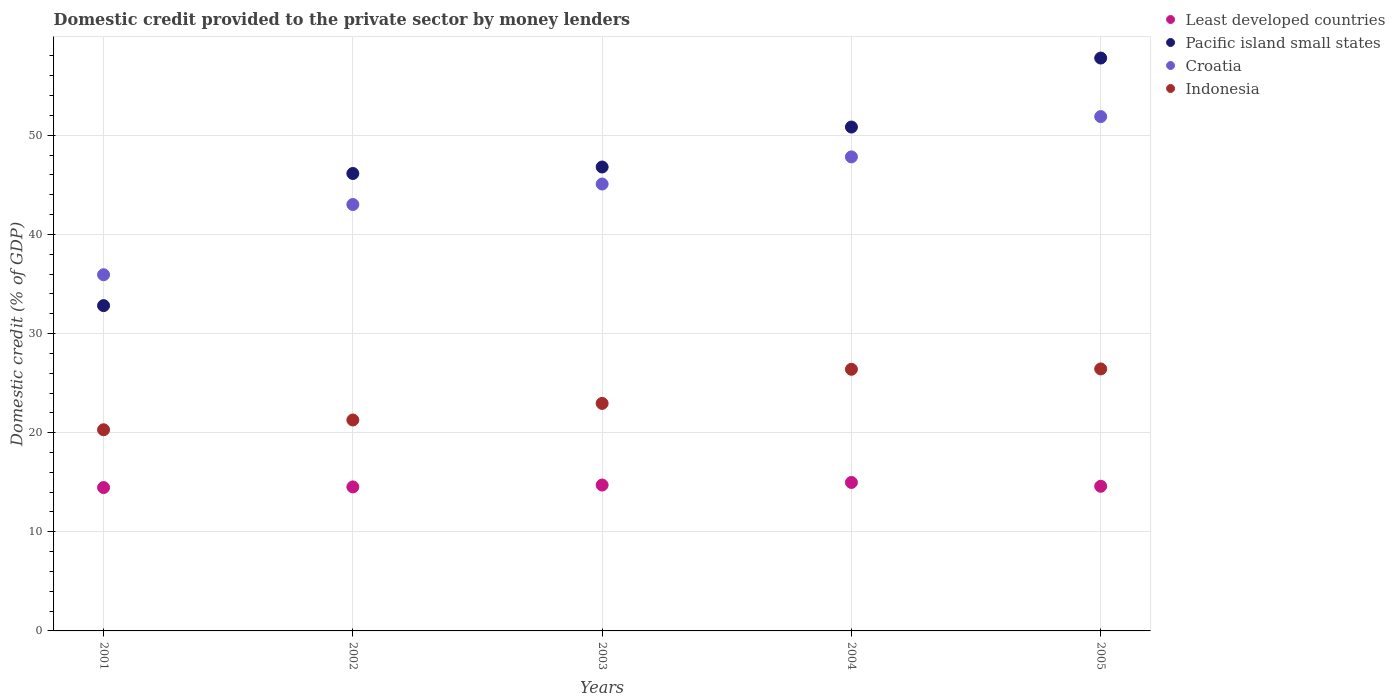What is the domestic credit provided to the private sector by money lenders in Least developed countries in 2001?
Keep it short and to the point. 14.46. Across all years, what is the maximum domestic credit provided to the private sector by money lenders in Least developed countries?
Your response must be concise. 14.98. Across all years, what is the minimum domestic credit provided to the private sector by money lenders in Pacific island small states?
Ensure brevity in your answer.  32.81. In which year was the domestic credit provided to the private sector by money lenders in Croatia maximum?
Provide a succinct answer. 2005. What is the total domestic credit provided to the private sector by money lenders in Indonesia in the graph?
Provide a short and direct response. 117.34. What is the difference between the domestic credit provided to the private sector by money lenders in Pacific island small states in 2003 and that in 2004?
Offer a very short reply. -4.03. What is the difference between the domestic credit provided to the private sector by money lenders in Croatia in 2002 and the domestic credit provided to the private sector by money lenders in Indonesia in 2005?
Offer a terse response. 16.59. What is the average domestic credit provided to the private sector by money lenders in Croatia per year?
Offer a very short reply. 44.74. In the year 2001, what is the difference between the domestic credit provided to the private sector by money lenders in Croatia and domestic credit provided to the private sector by money lenders in Least developed countries?
Offer a terse response. 21.47. What is the ratio of the domestic credit provided to the private sector by money lenders in Pacific island small states in 2001 to that in 2005?
Provide a succinct answer. 0.57. What is the difference between the highest and the second highest domestic credit provided to the private sector by money lenders in Indonesia?
Give a very brief answer. 0.04. What is the difference between the highest and the lowest domestic credit provided to the private sector by money lenders in Croatia?
Provide a short and direct response. 15.95. Is it the case that in every year, the sum of the domestic credit provided to the private sector by money lenders in Least developed countries and domestic credit provided to the private sector by money lenders in Croatia  is greater than the sum of domestic credit provided to the private sector by money lenders in Pacific island small states and domestic credit provided to the private sector by money lenders in Indonesia?
Give a very brief answer. Yes. Is it the case that in every year, the sum of the domestic credit provided to the private sector by money lenders in Least developed countries and domestic credit provided to the private sector by money lenders in Pacific island small states  is greater than the domestic credit provided to the private sector by money lenders in Croatia?
Your response must be concise. Yes. Is the domestic credit provided to the private sector by money lenders in Pacific island small states strictly greater than the domestic credit provided to the private sector by money lenders in Croatia over the years?
Your answer should be compact. No. Is the domestic credit provided to the private sector by money lenders in Pacific island small states strictly less than the domestic credit provided to the private sector by money lenders in Croatia over the years?
Offer a very short reply. No. How many dotlines are there?
Ensure brevity in your answer.  4. What is the difference between two consecutive major ticks on the Y-axis?
Your answer should be very brief. 10. Are the values on the major ticks of Y-axis written in scientific E-notation?
Your answer should be very brief. No. Does the graph contain grids?
Provide a short and direct response. Yes. How many legend labels are there?
Offer a very short reply. 4. How are the legend labels stacked?
Your answer should be compact. Vertical. What is the title of the graph?
Give a very brief answer. Domestic credit provided to the private sector by money lenders. Does "Bangladesh" appear as one of the legend labels in the graph?
Keep it short and to the point. No. What is the label or title of the Y-axis?
Keep it short and to the point. Domestic credit (% of GDP). What is the Domestic credit (% of GDP) of Least developed countries in 2001?
Your answer should be very brief. 14.46. What is the Domestic credit (% of GDP) of Pacific island small states in 2001?
Your response must be concise. 32.81. What is the Domestic credit (% of GDP) of Croatia in 2001?
Your answer should be very brief. 35.93. What is the Domestic credit (% of GDP) in Indonesia in 2001?
Your response must be concise. 20.29. What is the Domestic credit (% of GDP) of Least developed countries in 2002?
Give a very brief answer. 14.53. What is the Domestic credit (% of GDP) in Pacific island small states in 2002?
Provide a succinct answer. 46.14. What is the Domestic credit (% of GDP) of Croatia in 2002?
Make the answer very short. 43.01. What is the Domestic credit (% of GDP) of Indonesia in 2002?
Offer a terse response. 21.28. What is the Domestic credit (% of GDP) of Least developed countries in 2003?
Your answer should be very brief. 14.72. What is the Domestic credit (% of GDP) in Pacific island small states in 2003?
Offer a terse response. 46.8. What is the Domestic credit (% of GDP) in Croatia in 2003?
Give a very brief answer. 45.08. What is the Domestic credit (% of GDP) in Indonesia in 2003?
Provide a succinct answer. 22.95. What is the Domestic credit (% of GDP) in Least developed countries in 2004?
Make the answer very short. 14.98. What is the Domestic credit (% of GDP) in Pacific island small states in 2004?
Offer a very short reply. 50.83. What is the Domestic credit (% of GDP) of Croatia in 2004?
Make the answer very short. 47.82. What is the Domestic credit (% of GDP) in Indonesia in 2004?
Provide a short and direct response. 26.39. What is the Domestic credit (% of GDP) of Least developed countries in 2005?
Offer a very short reply. 14.59. What is the Domestic credit (% of GDP) in Pacific island small states in 2005?
Ensure brevity in your answer.  57.79. What is the Domestic credit (% of GDP) in Croatia in 2005?
Give a very brief answer. 51.88. What is the Domestic credit (% of GDP) of Indonesia in 2005?
Make the answer very short. 26.43. Across all years, what is the maximum Domestic credit (% of GDP) in Least developed countries?
Ensure brevity in your answer.  14.98. Across all years, what is the maximum Domestic credit (% of GDP) of Pacific island small states?
Your response must be concise. 57.79. Across all years, what is the maximum Domestic credit (% of GDP) in Croatia?
Make the answer very short. 51.88. Across all years, what is the maximum Domestic credit (% of GDP) of Indonesia?
Offer a very short reply. 26.43. Across all years, what is the minimum Domestic credit (% of GDP) of Least developed countries?
Your response must be concise. 14.46. Across all years, what is the minimum Domestic credit (% of GDP) in Pacific island small states?
Offer a very short reply. 32.81. Across all years, what is the minimum Domestic credit (% of GDP) of Croatia?
Ensure brevity in your answer.  35.93. Across all years, what is the minimum Domestic credit (% of GDP) in Indonesia?
Your answer should be very brief. 20.29. What is the total Domestic credit (% of GDP) of Least developed countries in the graph?
Make the answer very short. 73.27. What is the total Domestic credit (% of GDP) of Pacific island small states in the graph?
Provide a succinct answer. 234.37. What is the total Domestic credit (% of GDP) of Croatia in the graph?
Provide a succinct answer. 223.72. What is the total Domestic credit (% of GDP) of Indonesia in the graph?
Your answer should be compact. 117.34. What is the difference between the Domestic credit (% of GDP) in Least developed countries in 2001 and that in 2002?
Your answer should be very brief. -0.06. What is the difference between the Domestic credit (% of GDP) in Pacific island small states in 2001 and that in 2002?
Your answer should be very brief. -13.33. What is the difference between the Domestic credit (% of GDP) of Croatia in 2001 and that in 2002?
Keep it short and to the point. -7.08. What is the difference between the Domestic credit (% of GDP) in Indonesia in 2001 and that in 2002?
Keep it short and to the point. -0.99. What is the difference between the Domestic credit (% of GDP) of Least developed countries in 2001 and that in 2003?
Ensure brevity in your answer.  -0.25. What is the difference between the Domestic credit (% of GDP) in Pacific island small states in 2001 and that in 2003?
Your response must be concise. -13.98. What is the difference between the Domestic credit (% of GDP) in Croatia in 2001 and that in 2003?
Ensure brevity in your answer.  -9.15. What is the difference between the Domestic credit (% of GDP) in Indonesia in 2001 and that in 2003?
Give a very brief answer. -2.66. What is the difference between the Domestic credit (% of GDP) in Least developed countries in 2001 and that in 2004?
Make the answer very short. -0.51. What is the difference between the Domestic credit (% of GDP) of Pacific island small states in 2001 and that in 2004?
Ensure brevity in your answer.  -18.01. What is the difference between the Domestic credit (% of GDP) of Croatia in 2001 and that in 2004?
Offer a terse response. -11.89. What is the difference between the Domestic credit (% of GDP) of Indonesia in 2001 and that in 2004?
Ensure brevity in your answer.  -6.1. What is the difference between the Domestic credit (% of GDP) of Least developed countries in 2001 and that in 2005?
Offer a terse response. -0.13. What is the difference between the Domestic credit (% of GDP) of Pacific island small states in 2001 and that in 2005?
Ensure brevity in your answer.  -24.97. What is the difference between the Domestic credit (% of GDP) in Croatia in 2001 and that in 2005?
Offer a very short reply. -15.95. What is the difference between the Domestic credit (% of GDP) of Indonesia in 2001 and that in 2005?
Your answer should be compact. -6.14. What is the difference between the Domestic credit (% of GDP) of Least developed countries in 2002 and that in 2003?
Give a very brief answer. -0.19. What is the difference between the Domestic credit (% of GDP) in Pacific island small states in 2002 and that in 2003?
Provide a short and direct response. -0.65. What is the difference between the Domestic credit (% of GDP) in Croatia in 2002 and that in 2003?
Your answer should be compact. -2.07. What is the difference between the Domestic credit (% of GDP) in Indonesia in 2002 and that in 2003?
Offer a very short reply. -1.67. What is the difference between the Domestic credit (% of GDP) in Least developed countries in 2002 and that in 2004?
Make the answer very short. -0.45. What is the difference between the Domestic credit (% of GDP) in Pacific island small states in 2002 and that in 2004?
Offer a terse response. -4.69. What is the difference between the Domestic credit (% of GDP) in Croatia in 2002 and that in 2004?
Your response must be concise. -4.8. What is the difference between the Domestic credit (% of GDP) of Indonesia in 2002 and that in 2004?
Keep it short and to the point. -5.12. What is the difference between the Domestic credit (% of GDP) of Least developed countries in 2002 and that in 2005?
Your answer should be compact. -0.07. What is the difference between the Domestic credit (% of GDP) in Pacific island small states in 2002 and that in 2005?
Your answer should be very brief. -11.64. What is the difference between the Domestic credit (% of GDP) of Croatia in 2002 and that in 2005?
Give a very brief answer. -8.87. What is the difference between the Domestic credit (% of GDP) in Indonesia in 2002 and that in 2005?
Your answer should be compact. -5.15. What is the difference between the Domestic credit (% of GDP) in Least developed countries in 2003 and that in 2004?
Your answer should be very brief. -0.26. What is the difference between the Domestic credit (% of GDP) in Pacific island small states in 2003 and that in 2004?
Make the answer very short. -4.03. What is the difference between the Domestic credit (% of GDP) in Croatia in 2003 and that in 2004?
Offer a very short reply. -2.74. What is the difference between the Domestic credit (% of GDP) in Indonesia in 2003 and that in 2004?
Give a very brief answer. -3.44. What is the difference between the Domestic credit (% of GDP) of Least developed countries in 2003 and that in 2005?
Keep it short and to the point. 0.12. What is the difference between the Domestic credit (% of GDP) of Pacific island small states in 2003 and that in 2005?
Keep it short and to the point. -10.99. What is the difference between the Domestic credit (% of GDP) of Croatia in 2003 and that in 2005?
Ensure brevity in your answer.  -6.8. What is the difference between the Domestic credit (% of GDP) of Indonesia in 2003 and that in 2005?
Your response must be concise. -3.48. What is the difference between the Domestic credit (% of GDP) in Least developed countries in 2004 and that in 2005?
Your answer should be compact. 0.38. What is the difference between the Domestic credit (% of GDP) in Pacific island small states in 2004 and that in 2005?
Keep it short and to the point. -6.96. What is the difference between the Domestic credit (% of GDP) of Croatia in 2004 and that in 2005?
Offer a terse response. -4.07. What is the difference between the Domestic credit (% of GDP) of Indonesia in 2004 and that in 2005?
Ensure brevity in your answer.  -0.04. What is the difference between the Domestic credit (% of GDP) of Least developed countries in 2001 and the Domestic credit (% of GDP) of Pacific island small states in 2002?
Keep it short and to the point. -31.68. What is the difference between the Domestic credit (% of GDP) in Least developed countries in 2001 and the Domestic credit (% of GDP) in Croatia in 2002?
Provide a succinct answer. -28.55. What is the difference between the Domestic credit (% of GDP) in Least developed countries in 2001 and the Domestic credit (% of GDP) in Indonesia in 2002?
Offer a very short reply. -6.81. What is the difference between the Domestic credit (% of GDP) of Pacific island small states in 2001 and the Domestic credit (% of GDP) of Croatia in 2002?
Offer a very short reply. -10.2. What is the difference between the Domestic credit (% of GDP) in Pacific island small states in 2001 and the Domestic credit (% of GDP) in Indonesia in 2002?
Ensure brevity in your answer.  11.54. What is the difference between the Domestic credit (% of GDP) in Croatia in 2001 and the Domestic credit (% of GDP) in Indonesia in 2002?
Give a very brief answer. 14.65. What is the difference between the Domestic credit (% of GDP) of Least developed countries in 2001 and the Domestic credit (% of GDP) of Pacific island small states in 2003?
Offer a very short reply. -32.33. What is the difference between the Domestic credit (% of GDP) of Least developed countries in 2001 and the Domestic credit (% of GDP) of Croatia in 2003?
Offer a terse response. -30.62. What is the difference between the Domestic credit (% of GDP) of Least developed countries in 2001 and the Domestic credit (% of GDP) of Indonesia in 2003?
Your answer should be compact. -8.49. What is the difference between the Domestic credit (% of GDP) in Pacific island small states in 2001 and the Domestic credit (% of GDP) in Croatia in 2003?
Make the answer very short. -12.27. What is the difference between the Domestic credit (% of GDP) in Pacific island small states in 2001 and the Domestic credit (% of GDP) in Indonesia in 2003?
Your answer should be compact. 9.86. What is the difference between the Domestic credit (% of GDP) of Croatia in 2001 and the Domestic credit (% of GDP) of Indonesia in 2003?
Ensure brevity in your answer.  12.98. What is the difference between the Domestic credit (% of GDP) of Least developed countries in 2001 and the Domestic credit (% of GDP) of Pacific island small states in 2004?
Offer a very short reply. -36.37. What is the difference between the Domestic credit (% of GDP) in Least developed countries in 2001 and the Domestic credit (% of GDP) in Croatia in 2004?
Offer a terse response. -33.35. What is the difference between the Domestic credit (% of GDP) of Least developed countries in 2001 and the Domestic credit (% of GDP) of Indonesia in 2004?
Provide a succinct answer. -11.93. What is the difference between the Domestic credit (% of GDP) of Pacific island small states in 2001 and the Domestic credit (% of GDP) of Croatia in 2004?
Offer a terse response. -15. What is the difference between the Domestic credit (% of GDP) of Pacific island small states in 2001 and the Domestic credit (% of GDP) of Indonesia in 2004?
Keep it short and to the point. 6.42. What is the difference between the Domestic credit (% of GDP) of Croatia in 2001 and the Domestic credit (% of GDP) of Indonesia in 2004?
Your answer should be very brief. 9.54. What is the difference between the Domestic credit (% of GDP) in Least developed countries in 2001 and the Domestic credit (% of GDP) in Pacific island small states in 2005?
Your response must be concise. -43.33. What is the difference between the Domestic credit (% of GDP) of Least developed countries in 2001 and the Domestic credit (% of GDP) of Croatia in 2005?
Keep it short and to the point. -37.42. What is the difference between the Domestic credit (% of GDP) of Least developed countries in 2001 and the Domestic credit (% of GDP) of Indonesia in 2005?
Give a very brief answer. -11.97. What is the difference between the Domestic credit (% of GDP) in Pacific island small states in 2001 and the Domestic credit (% of GDP) in Croatia in 2005?
Give a very brief answer. -19.07. What is the difference between the Domestic credit (% of GDP) of Pacific island small states in 2001 and the Domestic credit (% of GDP) of Indonesia in 2005?
Offer a terse response. 6.39. What is the difference between the Domestic credit (% of GDP) in Croatia in 2001 and the Domestic credit (% of GDP) in Indonesia in 2005?
Your answer should be compact. 9.5. What is the difference between the Domestic credit (% of GDP) of Least developed countries in 2002 and the Domestic credit (% of GDP) of Pacific island small states in 2003?
Make the answer very short. -32.27. What is the difference between the Domestic credit (% of GDP) in Least developed countries in 2002 and the Domestic credit (% of GDP) in Croatia in 2003?
Your answer should be compact. -30.55. What is the difference between the Domestic credit (% of GDP) of Least developed countries in 2002 and the Domestic credit (% of GDP) of Indonesia in 2003?
Your answer should be compact. -8.42. What is the difference between the Domestic credit (% of GDP) of Pacific island small states in 2002 and the Domestic credit (% of GDP) of Croatia in 2003?
Keep it short and to the point. 1.06. What is the difference between the Domestic credit (% of GDP) in Pacific island small states in 2002 and the Domestic credit (% of GDP) in Indonesia in 2003?
Offer a terse response. 23.19. What is the difference between the Domestic credit (% of GDP) in Croatia in 2002 and the Domestic credit (% of GDP) in Indonesia in 2003?
Ensure brevity in your answer.  20.06. What is the difference between the Domestic credit (% of GDP) of Least developed countries in 2002 and the Domestic credit (% of GDP) of Pacific island small states in 2004?
Make the answer very short. -36.3. What is the difference between the Domestic credit (% of GDP) of Least developed countries in 2002 and the Domestic credit (% of GDP) of Croatia in 2004?
Provide a succinct answer. -33.29. What is the difference between the Domestic credit (% of GDP) in Least developed countries in 2002 and the Domestic credit (% of GDP) in Indonesia in 2004?
Offer a terse response. -11.87. What is the difference between the Domestic credit (% of GDP) of Pacific island small states in 2002 and the Domestic credit (% of GDP) of Croatia in 2004?
Your response must be concise. -1.67. What is the difference between the Domestic credit (% of GDP) of Pacific island small states in 2002 and the Domestic credit (% of GDP) of Indonesia in 2004?
Offer a very short reply. 19.75. What is the difference between the Domestic credit (% of GDP) of Croatia in 2002 and the Domestic credit (% of GDP) of Indonesia in 2004?
Give a very brief answer. 16.62. What is the difference between the Domestic credit (% of GDP) in Least developed countries in 2002 and the Domestic credit (% of GDP) in Pacific island small states in 2005?
Provide a short and direct response. -43.26. What is the difference between the Domestic credit (% of GDP) in Least developed countries in 2002 and the Domestic credit (% of GDP) in Croatia in 2005?
Your response must be concise. -37.36. What is the difference between the Domestic credit (% of GDP) in Least developed countries in 2002 and the Domestic credit (% of GDP) in Indonesia in 2005?
Give a very brief answer. -11.9. What is the difference between the Domestic credit (% of GDP) of Pacific island small states in 2002 and the Domestic credit (% of GDP) of Croatia in 2005?
Your answer should be compact. -5.74. What is the difference between the Domestic credit (% of GDP) in Pacific island small states in 2002 and the Domestic credit (% of GDP) in Indonesia in 2005?
Your answer should be compact. 19.72. What is the difference between the Domestic credit (% of GDP) in Croatia in 2002 and the Domestic credit (% of GDP) in Indonesia in 2005?
Provide a succinct answer. 16.59. What is the difference between the Domestic credit (% of GDP) of Least developed countries in 2003 and the Domestic credit (% of GDP) of Pacific island small states in 2004?
Ensure brevity in your answer.  -36.11. What is the difference between the Domestic credit (% of GDP) of Least developed countries in 2003 and the Domestic credit (% of GDP) of Croatia in 2004?
Give a very brief answer. -33.1. What is the difference between the Domestic credit (% of GDP) in Least developed countries in 2003 and the Domestic credit (% of GDP) in Indonesia in 2004?
Offer a terse response. -11.68. What is the difference between the Domestic credit (% of GDP) of Pacific island small states in 2003 and the Domestic credit (% of GDP) of Croatia in 2004?
Make the answer very short. -1.02. What is the difference between the Domestic credit (% of GDP) in Pacific island small states in 2003 and the Domestic credit (% of GDP) in Indonesia in 2004?
Keep it short and to the point. 20.4. What is the difference between the Domestic credit (% of GDP) in Croatia in 2003 and the Domestic credit (% of GDP) in Indonesia in 2004?
Ensure brevity in your answer.  18.69. What is the difference between the Domestic credit (% of GDP) in Least developed countries in 2003 and the Domestic credit (% of GDP) in Pacific island small states in 2005?
Your answer should be compact. -43.07. What is the difference between the Domestic credit (% of GDP) in Least developed countries in 2003 and the Domestic credit (% of GDP) in Croatia in 2005?
Offer a terse response. -37.17. What is the difference between the Domestic credit (% of GDP) in Least developed countries in 2003 and the Domestic credit (% of GDP) in Indonesia in 2005?
Give a very brief answer. -11.71. What is the difference between the Domestic credit (% of GDP) of Pacific island small states in 2003 and the Domestic credit (% of GDP) of Croatia in 2005?
Give a very brief answer. -5.09. What is the difference between the Domestic credit (% of GDP) in Pacific island small states in 2003 and the Domestic credit (% of GDP) in Indonesia in 2005?
Offer a very short reply. 20.37. What is the difference between the Domestic credit (% of GDP) in Croatia in 2003 and the Domestic credit (% of GDP) in Indonesia in 2005?
Your response must be concise. 18.65. What is the difference between the Domestic credit (% of GDP) of Least developed countries in 2004 and the Domestic credit (% of GDP) of Pacific island small states in 2005?
Ensure brevity in your answer.  -42.81. What is the difference between the Domestic credit (% of GDP) in Least developed countries in 2004 and the Domestic credit (% of GDP) in Croatia in 2005?
Your answer should be compact. -36.91. What is the difference between the Domestic credit (% of GDP) in Least developed countries in 2004 and the Domestic credit (% of GDP) in Indonesia in 2005?
Offer a very short reply. -11.45. What is the difference between the Domestic credit (% of GDP) of Pacific island small states in 2004 and the Domestic credit (% of GDP) of Croatia in 2005?
Give a very brief answer. -1.05. What is the difference between the Domestic credit (% of GDP) in Pacific island small states in 2004 and the Domestic credit (% of GDP) in Indonesia in 2005?
Make the answer very short. 24.4. What is the difference between the Domestic credit (% of GDP) of Croatia in 2004 and the Domestic credit (% of GDP) of Indonesia in 2005?
Keep it short and to the point. 21.39. What is the average Domestic credit (% of GDP) in Least developed countries per year?
Provide a succinct answer. 14.65. What is the average Domestic credit (% of GDP) of Pacific island small states per year?
Offer a very short reply. 46.87. What is the average Domestic credit (% of GDP) of Croatia per year?
Your response must be concise. 44.74. What is the average Domestic credit (% of GDP) of Indonesia per year?
Your answer should be compact. 23.47. In the year 2001, what is the difference between the Domestic credit (% of GDP) in Least developed countries and Domestic credit (% of GDP) in Pacific island small states?
Your answer should be very brief. -18.35. In the year 2001, what is the difference between the Domestic credit (% of GDP) of Least developed countries and Domestic credit (% of GDP) of Croatia?
Give a very brief answer. -21.47. In the year 2001, what is the difference between the Domestic credit (% of GDP) in Least developed countries and Domestic credit (% of GDP) in Indonesia?
Make the answer very short. -5.83. In the year 2001, what is the difference between the Domestic credit (% of GDP) in Pacific island small states and Domestic credit (% of GDP) in Croatia?
Give a very brief answer. -3.12. In the year 2001, what is the difference between the Domestic credit (% of GDP) in Pacific island small states and Domestic credit (% of GDP) in Indonesia?
Provide a short and direct response. 12.52. In the year 2001, what is the difference between the Domestic credit (% of GDP) of Croatia and Domestic credit (% of GDP) of Indonesia?
Make the answer very short. 15.64. In the year 2002, what is the difference between the Domestic credit (% of GDP) in Least developed countries and Domestic credit (% of GDP) in Pacific island small states?
Your answer should be compact. -31.62. In the year 2002, what is the difference between the Domestic credit (% of GDP) of Least developed countries and Domestic credit (% of GDP) of Croatia?
Provide a short and direct response. -28.49. In the year 2002, what is the difference between the Domestic credit (% of GDP) of Least developed countries and Domestic credit (% of GDP) of Indonesia?
Your answer should be very brief. -6.75. In the year 2002, what is the difference between the Domestic credit (% of GDP) in Pacific island small states and Domestic credit (% of GDP) in Croatia?
Offer a terse response. 3.13. In the year 2002, what is the difference between the Domestic credit (% of GDP) in Pacific island small states and Domestic credit (% of GDP) in Indonesia?
Provide a short and direct response. 24.87. In the year 2002, what is the difference between the Domestic credit (% of GDP) of Croatia and Domestic credit (% of GDP) of Indonesia?
Provide a succinct answer. 21.74. In the year 2003, what is the difference between the Domestic credit (% of GDP) of Least developed countries and Domestic credit (% of GDP) of Pacific island small states?
Your response must be concise. -32.08. In the year 2003, what is the difference between the Domestic credit (% of GDP) of Least developed countries and Domestic credit (% of GDP) of Croatia?
Ensure brevity in your answer.  -30.36. In the year 2003, what is the difference between the Domestic credit (% of GDP) in Least developed countries and Domestic credit (% of GDP) in Indonesia?
Provide a succinct answer. -8.23. In the year 2003, what is the difference between the Domestic credit (% of GDP) of Pacific island small states and Domestic credit (% of GDP) of Croatia?
Make the answer very short. 1.72. In the year 2003, what is the difference between the Domestic credit (% of GDP) of Pacific island small states and Domestic credit (% of GDP) of Indonesia?
Give a very brief answer. 23.85. In the year 2003, what is the difference between the Domestic credit (% of GDP) in Croatia and Domestic credit (% of GDP) in Indonesia?
Your answer should be very brief. 22.13. In the year 2004, what is the difference between the Domestic credit (% of GDP) of Least developed countries and Domestic credit (% of GDP) of Pacific island small states?
Make the answer very short. -35.85. In the year 2004, what is the difference between the Domestic credit (% of GDP) in Least developed countries and Domestic credit (% of GDP) in Croatia?
Your answer should be very brief. -32.84. In the year 2004, what is the difference between the Domestic credit (% of GDP) of Least developed countries and Domestic credit (% of GDP) of Indonesia?
Keep it short and to the point. -11.42. In the year 2004, what is the difference between the Domestic credit (% of GDP) in Pacific island small states and Domestic credit (% of GDP) in Croatia?
Your answer should be compact. 3.01. In the year 2004, what is the difference between the Domestic credit (% of GDP) of Pacific island small states and Domestic credit (% of GDP) of Indonesia?
Offer a terse response. 24.44. In the year 2004, what is the difference between the Domestic credit (% of GDP) of Croatia and Domestic credit (% of GDP) of Indonesia?
Offer a terse response. 21.42. In the year 2005, what is the difference between the Domestic credit (% of GDP) in Least developed countries and Domestic credit (% of GDP) in Pacific island small states?
Provide a succinct answer. -43.19. In the year 2005, what is the difference between the Domestic credit (% of GDP) of Least developed countries and Domestic credit (% of GDP) of Croatia?
Provide a short and direct response. -37.29. In the year 2005, what is the difference between the Domestic credit (% of GDP) in Least developed countries and Domestic credit (% of GDP) in Indonesia?
Offer a terse response. -11.83. In the year 2005, what is the difference between the Domestic credit (% of GDP) in Pacific island small states and Domestic credit (% of GDP) in Croatia?
Your answer should be very brief. 5.91. In the year 2005, what is the difference between the Domestic credit (% of GDP) in Pacific island small states and Domestic credit (% of GDP) in Indonesia?
Provide a short and direct response. 31.36. In the year 2005, what is the difference between the Domestic credit (% of GDP) of Croatia and Domestic credit (% of GDP) of Indonesia?
Ensure brevity in your answer.  25.45. What is the ratio of the Domestic credit (% of GDP) in Pacific island small states in 2001 to that in 2002?
Provide a succinct answer. 0.71. What is the ratio of the Domestic credit (% of GDP) of Croatia in 2001 to that in 2002?
Your answer should be compact. 0.84. What is the ratio of the Domestic credit (% of GDP) of Indonesia in 2001 to that in 2002?
Offer a terse response. 0.95. What is the ratio of the Domestic credit (% of GDP) of Least developed countries in 2001 to that in 2003?
Provide a succinct answer. 0.98. What is the ratio of the Domestic credit (% of GDP) of Pacific island small states in 2001 to that in 2003?
Offer a terse response. 0.7. What is the ratio of the Domestic credit (% of GDP) in Croatia in 2001 to that in 2003?
Your response must be concise. 0.8. What is the ratio of the Domestic credit (% of GDP) in Indonesia in 2001 to that in 2003?
Make the answer very short. 0.88. What is the ratio of the Domestic credit (% of GDP) in Least developed countries in 2001 to that in 2004?
Your response must be concise. 0.97. What is the ratio of the Domestic credit (% of GDP) in Pacific island small states in 2001 to that in 2004?
Your answer should be very brief. 0.65. What is the ratio of the Domestic credit (% of GDP) in Croatia in 2001 to that in 2004?
Provide a succinct answer. 0.75. What is the ratio of the Domestic credit (% of GDP) in Indonesia in 2001 to that in 2004?
Your answer should be compact. 0.77. What is the ratio of the Domestic credit (% of GDP) of Least developed countries in 2001 to that in 2005?
Your answer should be very brief. 0.99. What is the ratio of the Domestic credit (% of GDP) in Pacific island small states in 2001 to that in 2005?
Your answer should be compact. 0.57. What is the ratio of the Domestic credit (% of GDP) in Croatia in 2001 to that in 2005?
Your answer should be compact. 0.69. What is the ratio of the Domestic credit (% of GDP) in Indonesia in 2001 to that in 2005?
Keep it short and to the point. 0.77. What is the ratio of the Domestic credit (% of GDP) of Least developed countries in 2002 to that in 2003?
Your answer should be very brief. 0.99. What is the ratio of the Domestic credit (% of GDP) of Pacific island small states in 2002 to that in 2003?
Your answer should be very brief. 0.99. What is the ratio of the Domestic credit (% of GDP) of Croatia in 2002 to that in 2003?
Ensure brevity in your answer.  0.95. What is the ratio of the Domestic credit (% of GDP) of Indonesia in 2002 to that in 2003?
Your response must be concise. 0.93. What is the ratio of the Domestic credit (% of GDP) of Least developed countries in 2002 to that in 2004?
Your answer should be very brief. 0.97. What is the ratio of the Domestic credit (% of GDP) of Pacific island small states in 2002 to that in 2004?
Your answer should be very brief. 0.91. What is the ratio of the Domestic credit (% of GDP) in Croatia in 2002 to that in 2004?
Offer a very short reply. 0.9. What is the ratio of the Domestic credit (% of GDP) of Indonesia in 2002 to that in 2004?
Make the answer very short. 0.81. What is the ratio of the Domestic credit (% of GDP) of Pacific island small states in 2002 to that in 2005?
Provide a succinct answer. 0.8. What is the ratio of the Domestic credit (% of GDP) of Croatia in 2002 to that in 2005?
Offer a terse response. 0.83. What is the ratio of the Domestic credit (% of GDP) in Indonesia in 2002 to that in 2005?
Provide a succinct answer. 0.81. What is the ratio of the Domestic credit (% of GDP) in Least developed countries in 2003 to that in 2004?
Give a very brief answer. 0.98. What is the ratio of the Domestic credit (% of GDP) of Pacific island small states in 2003 to that in 2004?
Give a very brief answer. 0.92. What is the ratio of the Domestic credit (% of GDP) of Croatia in 2003 to that in 2004?
Offer a very short reply. 0.94. What is the ratio of the Domestic credit (% of GDP) of Indonesia in 2003 to that in 2004?
Make the answer very short. 0.87. What is the ratio of the Domestic credit (% of GDP) of Least developed countries in 2003 to that in 2005?
Offer a terse response. 1.01. What is the ratio of the Domestic credit (% of GDP) in Pacific island small states in 2003 to that in 2005?
Your answer should be compact. 0.81. What is the ratio of the Domestic credit (% of GDP) in Croatia in 2003 to that in 2005?
Your answer should be very brief. 0.87. What is the ratio of the Domestic credit (% of GDP) in Indonesia in 2003 to that in 2005?
Ensure brevity in your answer.  0.87. What is the ratio of the Domestic credit (% of GDP) in Least developed countries in 2004 to that in 2005?
Provide a short and direct response. 1.03. What is the ratio of the Domestic credit (% of GDP) of Pacific island small states in 2004 to that in 2005?
Your answer should be very brief. 0.88. What is the ratio of the Domestic credit (% of GDP) in Croatia in 2004 to that in 2005?
Offer a very short reply. 0.92. What is the difference between the highest and the second highest Domestic credit (% of GDP) in Least developed countries?
Provide a succinct answer. 0.26. What is the difference between the highest and the second highest Domestic credit (% of GDP) in Pacific island small states?
Make the answer very short. 6.96. What is the difference between the highest and the second highest Domestic credit (% of GDP) of Croatia?
Offer a terse response. 4.07. What is the difference between the highest and the second highest Domestic credit (% of GDP) in Indonesia?
Your answer should be compact. 0.04. What is the difference between the highest and the lowest Domestic credit (% of GDP) in Least developed countries?
Your answer should be compact. 0.51. What is the difference between the highest and the lowest Domestic credit (% of GDP) of Pacific island small states?
Provide a succinct answer. 24.97. What is the difference between the highest and the lowest Domestic credit (% of GDP) in Croatia?
Offer a very short reply. 15.95. What is the difference between the highest and the lowest Domestic credit (% of GDP) of Indonesia?
Offer a terse response. 6.14. 